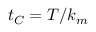Convert formula to latex. <formula><loc_0><loc_0><loc_500><loc_500>t _ { C } = T / k _ { m }</formula> 